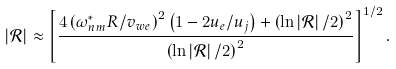<formula> <loc_0><loc_0><loc_500><loc_500>\left | \mathcal { R } \right | \approx \left [ \frac { 4 \left ( \omega _ { n m } ^ { \ast } R / v _ { w e } \right ) ^ { 2 } \left ( 1 - 2 u _ { e } / u _ { j } \right ) + \left ( \ln \left | \mathcal { R } \right | / 2 \right ) ^ { 2 } } { \left ( \ln \left | \mathcal { R } \right | / 2 \right ) ^ { 2 } } \right ] ^ { 1 / 2 } .</formula> 